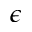<formula> <loc_0><loc_0><loc_500><loc_500>\epsilon</formula> 